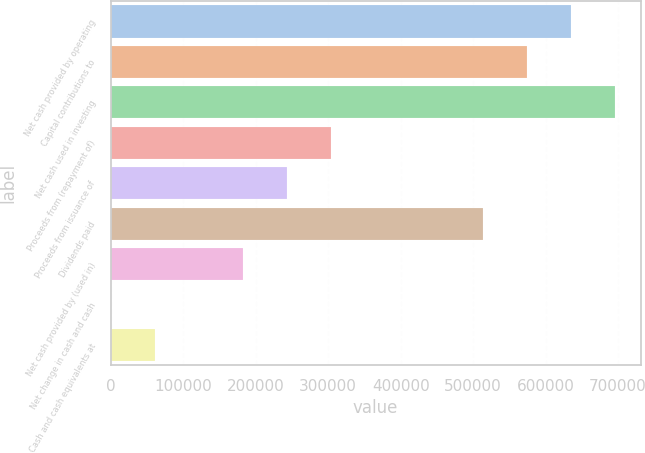Convert chart. <chart><loc_0><loc_0><loc_500><loc_500><bar_chart><fcel>Net cash provided by operating<fcel>Capital contributions to<fcel>Net cash used in investing<fcel>Proceeds from (repayment of)<fcel>Proceeds from issuance of<fcel>Dividends paid<fcel>Net cash provided by (used in)<fcel>Net change in cash and cash<fcel>Cash and cash equivalents at<nl><fcel>635541<fcel>574792<fcel>696291<fcel>303904<fcel>243155<fcel>514042<fcel>182405<fcel>156<fcel>60905.7<nl></chart> 